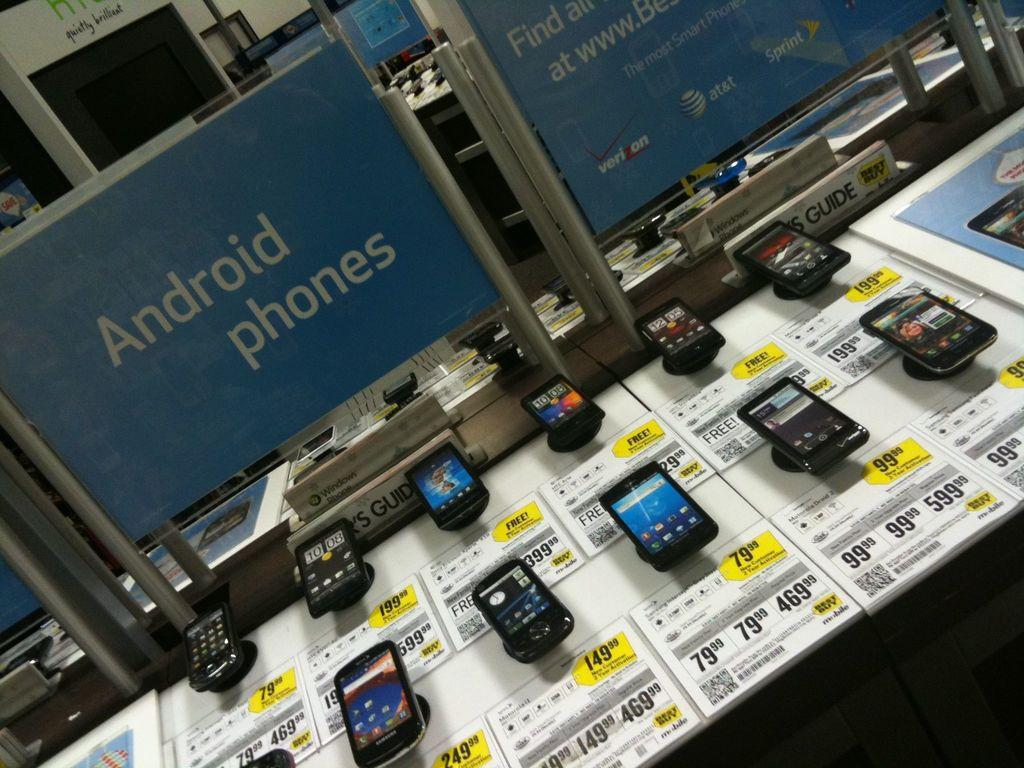<image>
Offer a succinct explanation of the picture presented. A display of Android phones, each with the price in front of it. 